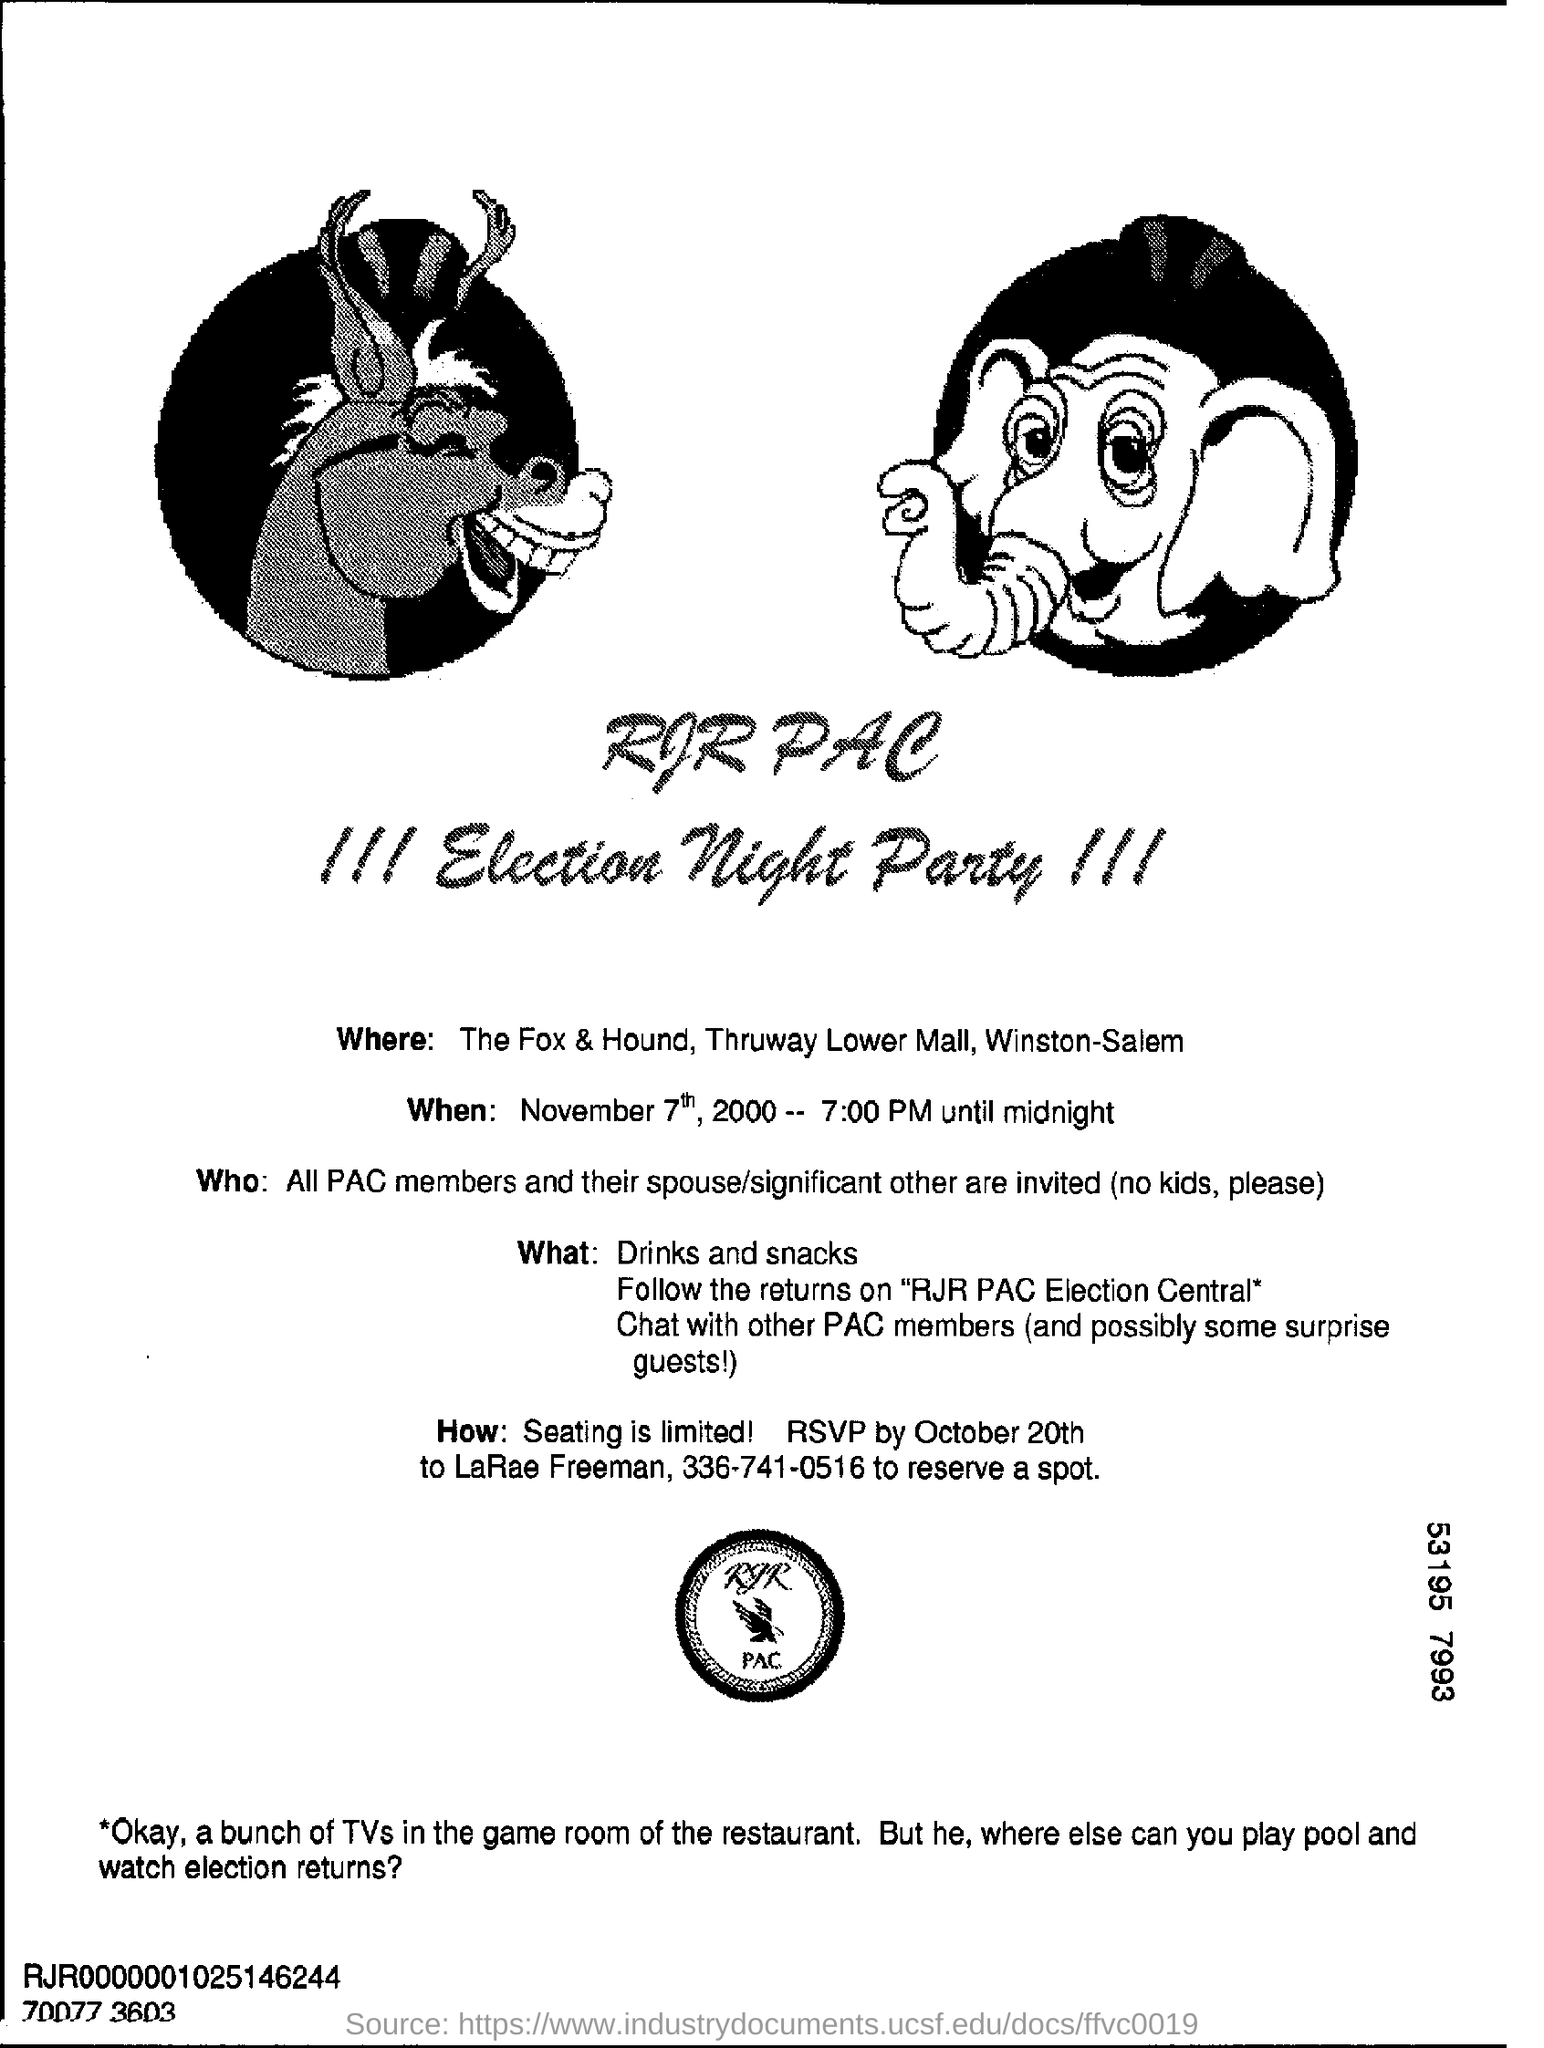Where is the Election Night Party?
Offer a very short reply. The Fox & Hound, Thruway Lowermall, Winston-Salem. At what time is the party?
Provide a succinct answer. 7:00 PM UNTIL MIDNIGHT. Are kids allowed in the party?
Your response must be concise. NO KIDS. By when should RSVP be sent?
Your answer should be compact. OCTOBER 20TH. To whom should RSVP be sent?
Provide a short and direct response. LaRae Freeman. On which number should you call to reserve a spot?
Your answer should be very brief. 336-741-0516. 